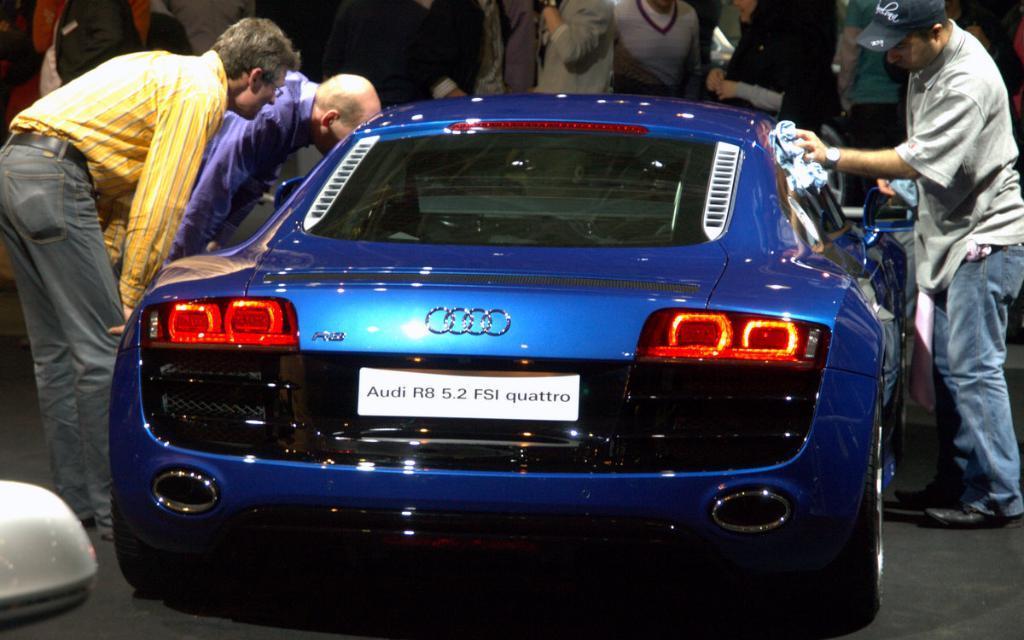In one or two sentences, can you explain what this image depicts? In this image in the center there is a car which is blue in colour. On the left side of the car there are two persons standing and peeing in the car. On the right side of the car there is a person standing and cleaning the car. In the background there are persons standing. On the bottom left there is a white colour object which is visible. 